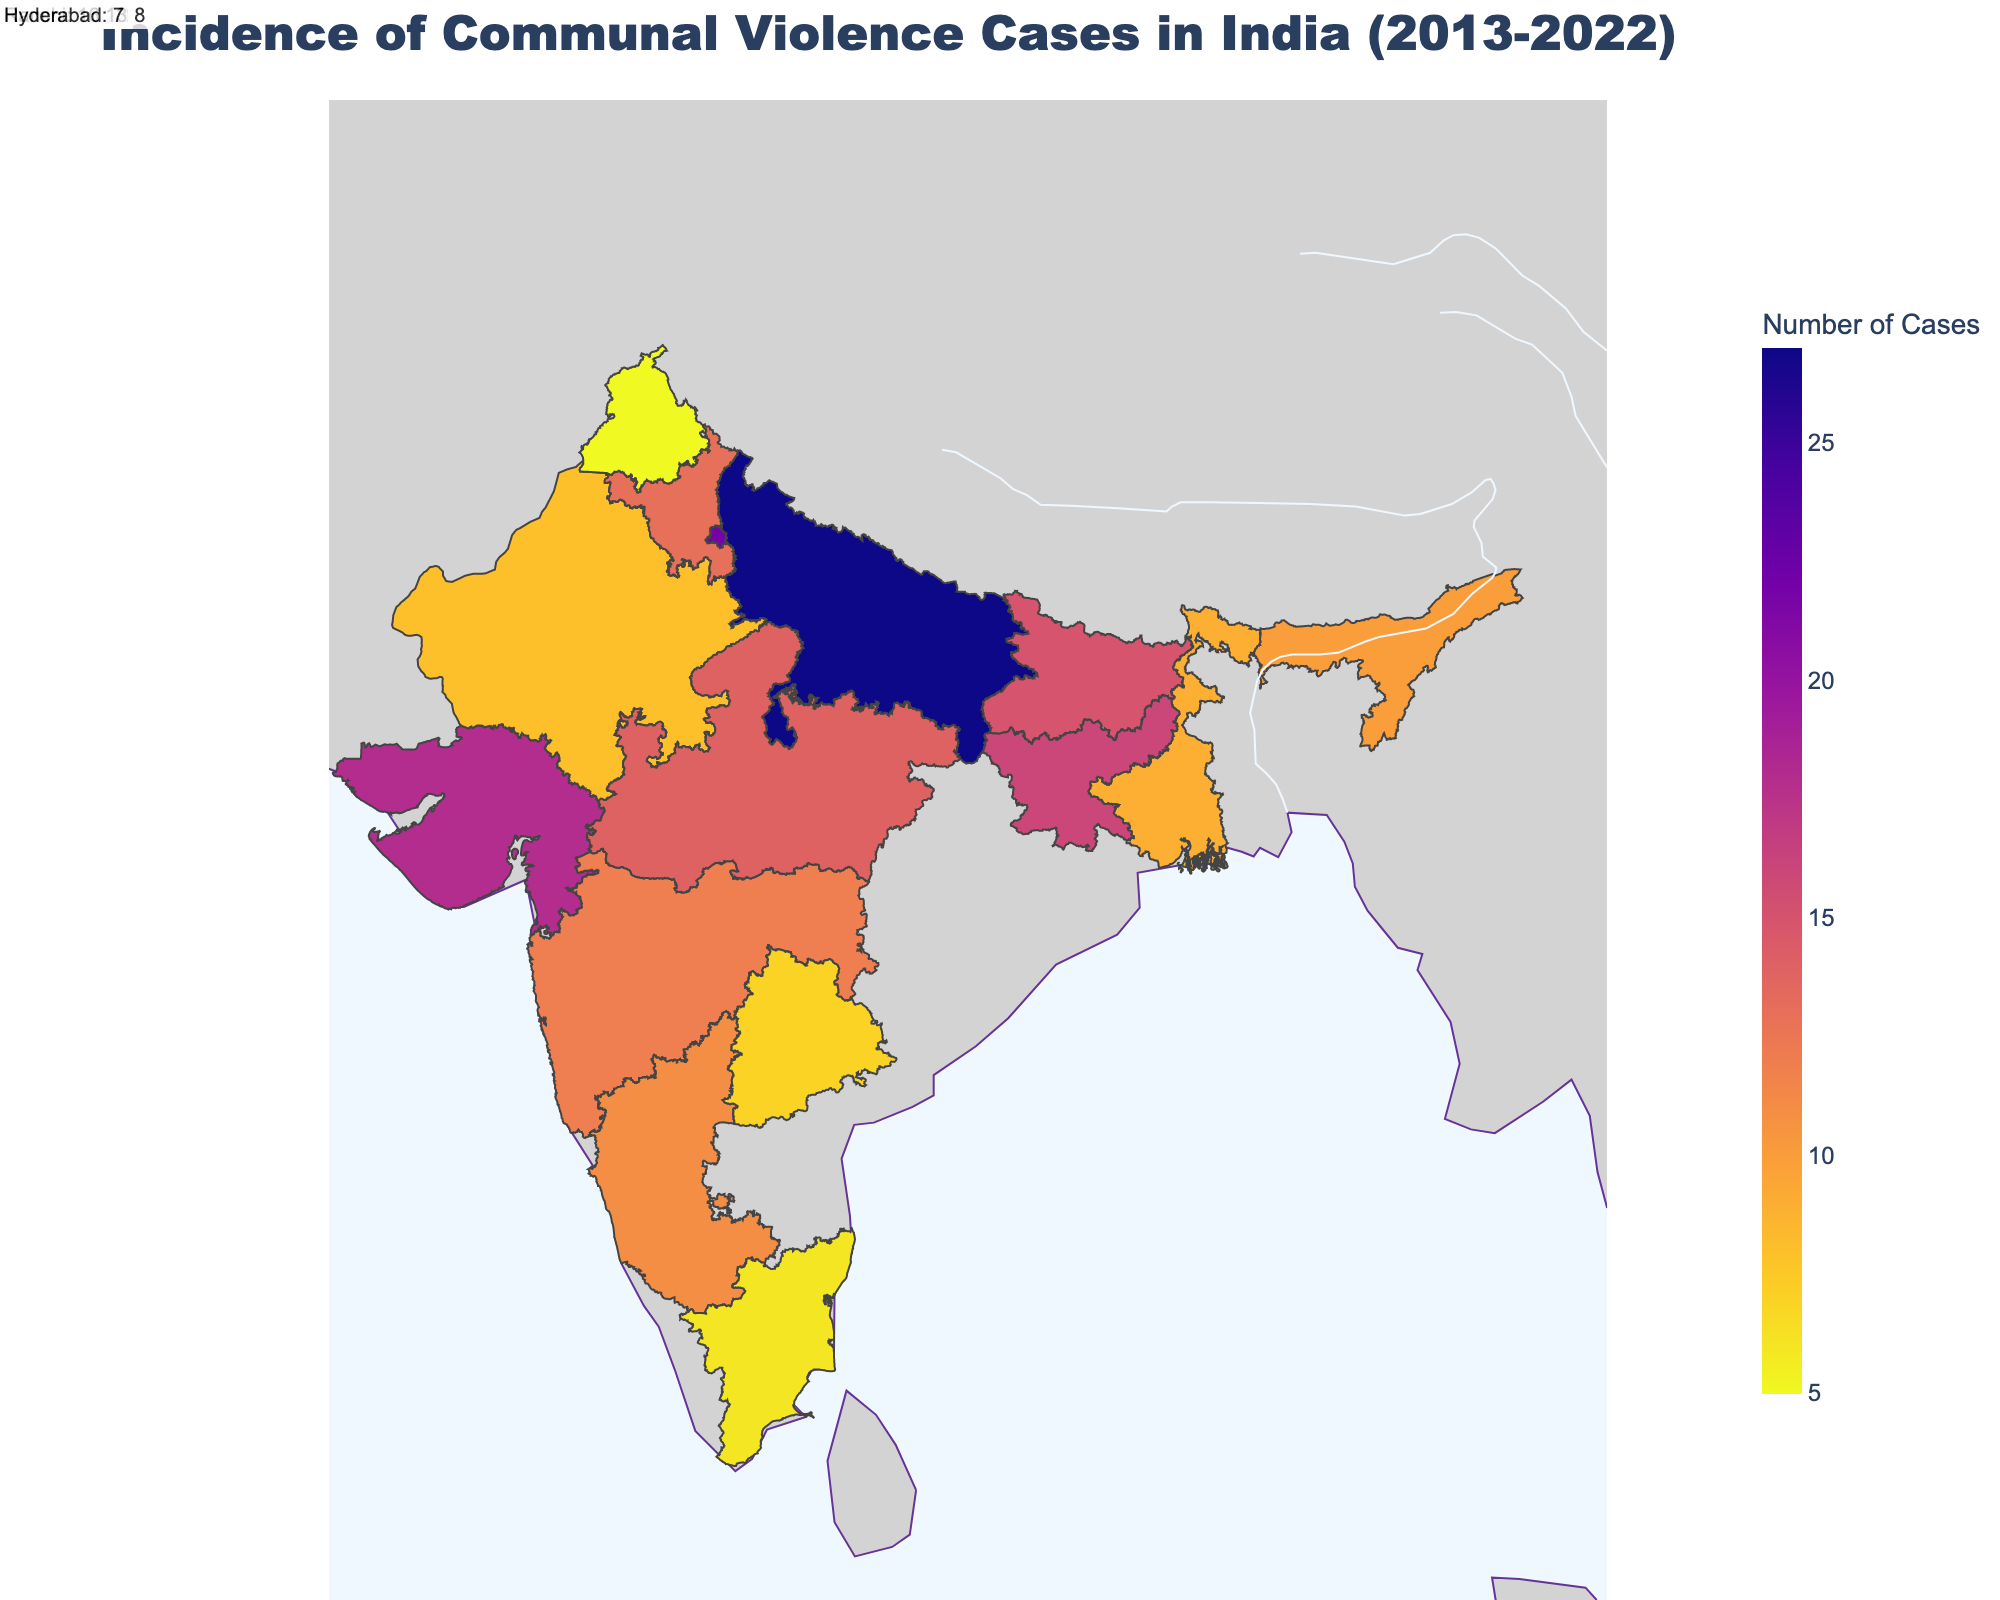What is the title of the figure? The title of the figure is prominently displayed at the top and serves as a summary of the content being visualized. In this case, the title is "Incidence of Communal Violence Cases in India (2013-2022)".
Answer: Incidence of Communal Violence Cases in India (2013-2022) Which state reported the highest number of communal violence cases in a single year? To find the state with the highest number of communal violence cases, look for the state with the darkest color shade on the map and confirm the number in the hover tooltip or the annotations. Uttar Pradesh has the highest number of cases, with Meerut reporting 27 cases in 2013.
Answer: Uttar Pradesh What is the range of the number of communal violence cases reported in the visual? By observing the color axis color bar that indicates the range, you can see that the range spans from 5 to 27 cases.
Answer: 5 to 27 How many cities in the visual reported communal violence cases in 2017? To determine the number of cities that reported cases in 2017, count the records or annotations in the visual that indicate the year 2017. Two cities (Mumbai and Gurugram) reported cases in 2017.
Answer: 2 Which city reported the lowest number of communal violence cases, and in which year? The lightest color on the map indicates the lowest number of cases. By checking the hover tooltips or annotations, you see that Amritsar, Punjab reported the lowest number of cases (5 cases) in 2019.
Answer: Amritsar, 2019 What is the average number of communal violence cases reported by Meerut and New Delhi in 2013? First note the number of cases reported in 2013 for both Meerut (27 cases) and New Delhi (22 cases). Calculate the average by summing these values (27 + 22 = 49) and then dividing by 2 (49 / 2 = 24.5).
Answer: 24.5 Compare the communal violence cases reported in Mangalore (2018) and Coimbatore (2022). Which city reported more cases? Look at the visual and note the number of cases for Mangalore in 2018 (11 cases) and Coimbatore in 2022 (6 cases). Mangalore reported more cases than Coimbatore.
Answer: Mangalore Which states show a decrease in the number of communal violence cases over time based on the annotations or hover tooltips? Multiple steps are required to determine this: check each state's sequence of reported years to detect any downward trend in the number of cases. For instance, Gujarat shows a decrease from Ahmedabad's 18 cases in 2015.
Answer: Gujarat Is there a significant concentration of communal violence cases in any particular region of India? Analyze the geographic distribution of the darker shades, which represent higher cases. The northern region, particularly Uttar Pradesh and Delhi, shows a significant concentration.
Answer: Northern region 